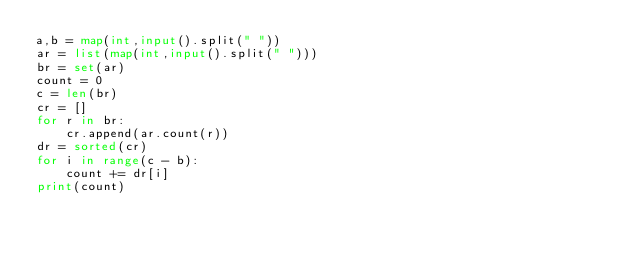Convert code to text. <code><loc_0><loc_0><loc_500><loc_500><_Python_>a,b = map(int,input().split(" "))
ar = list(map(int,input().split(" ")))
br = set(ar)
count = 0
c = len(br)
cr = []
for r in br:
    cr.append(ar.count(r))
dr = sorted(cr)
for i in range(c - b):
    count += dr[i]
print(count)</code> 